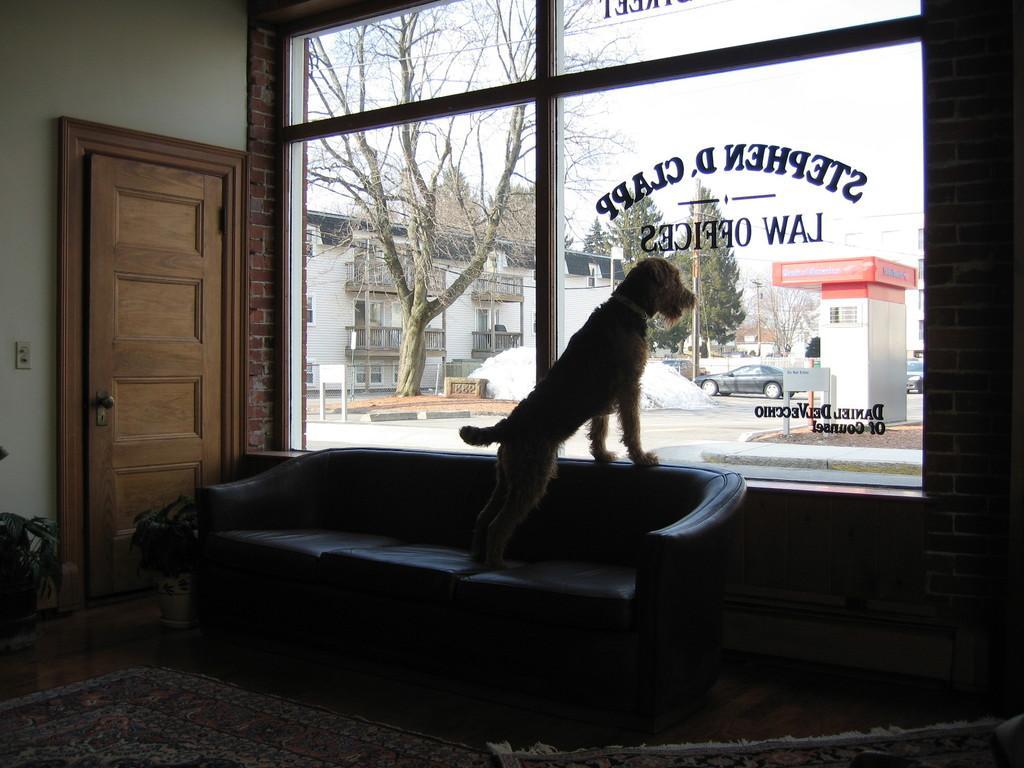In one or two sentences, can you explain what this image depicts? This is a picture of the inside of the house in this image there is one couch on that couch one dog is there on the floor there is carpet on the right side of the image there is one window and on the left side there is one door and wall and in the middle of the image there is one tree and in the background there are houses and car and road are there and some sand is there on the left side of the image and in the middle of the image there is snow and on the top of the image there is sky. 